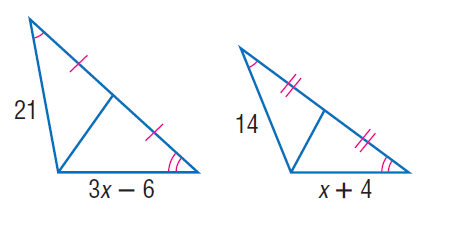Question: Find x.
Choices:
A. 6
B. 8
C. 10
D. 12
Answer with the letter. Answer: B 